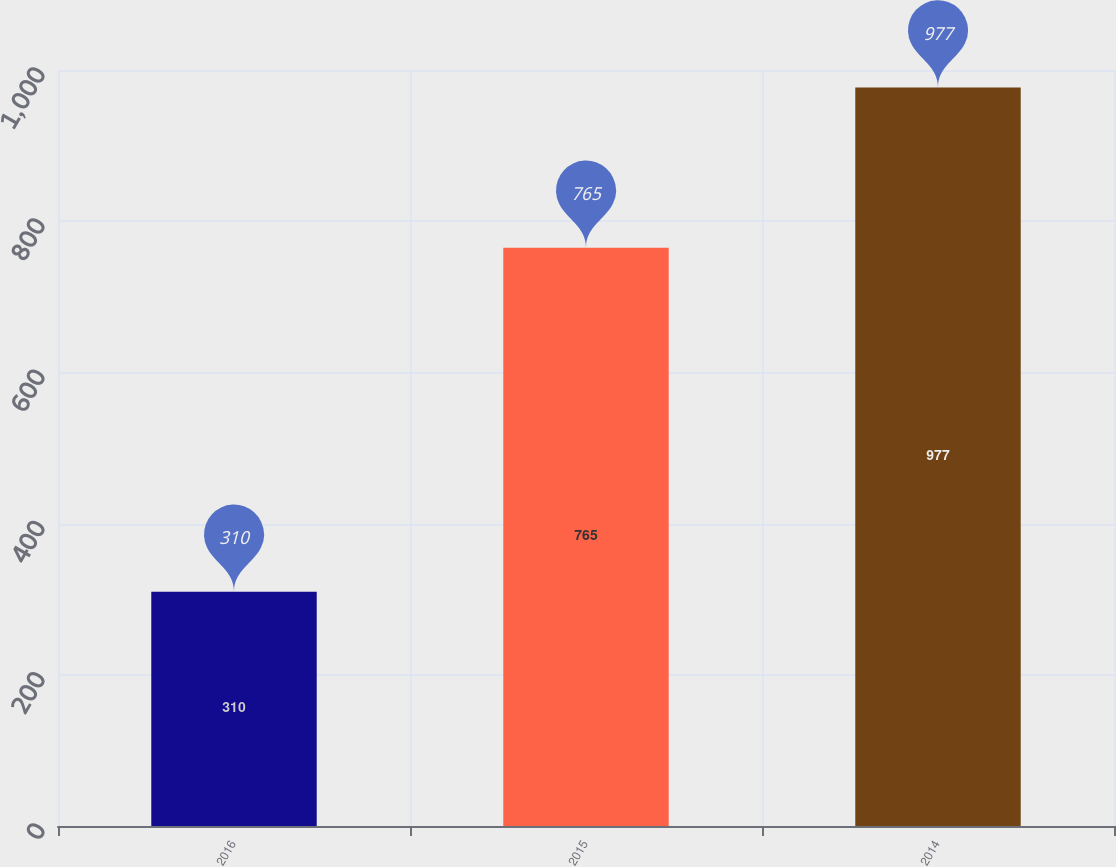Convert chart to OTSL. <chart><loc_0><loc_0><loc_500><loc_500><bar_chart><fcel>2016<fcel>2015<fcel>2014<nl><fcel>310<fcel>765<fcel>977<nl></chart> 